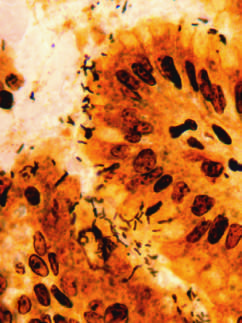re spiral-shaped helicobacter pylori bacilli highlighted in this warthin-starry silver stain?
Answer the question using a single word or phrase. Yes 